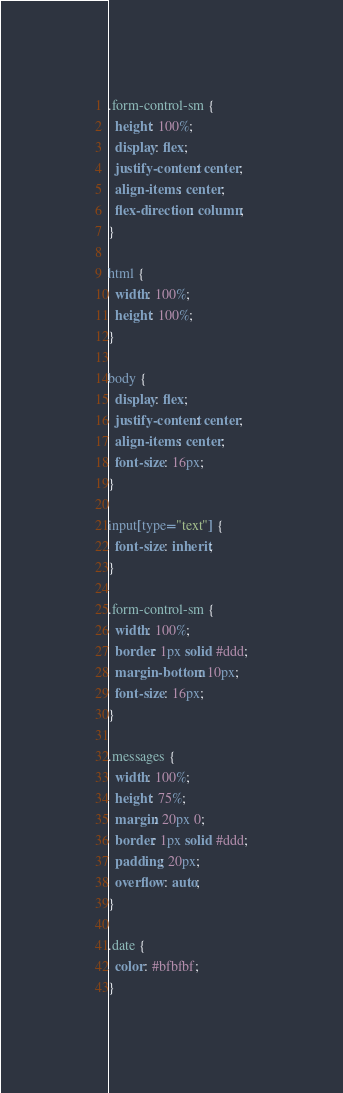Convert code to text. <code><loc_0><loc_0><loc_500><loc_500><_CSS_>.form-control-sm {
  height: 100%;
  display: flex;
  justify-content: center;
  align-items: center;
  flex-direction: column;
}

html {
  width: 100%;
  height: 100%;
}

body {
  display: flex;
  justify-content: center;
  align-items: center;
  font-size: 16px;
}

input[type="text"] {
  font-size: inherit;
}

.form-control-sm {
  width: 100%;
  border: 1px solid #ddd;
  margin-bottom: 10px;
  font-size: 16px;
}

.messages {
  width: 100%;
  height: 75%;
  margin: 20px 0;
  border: 1px solid #ddd;
  padding: 20px;
  overflow: auto;
}

.date {
  color: #bfbfbf;
}</code> 